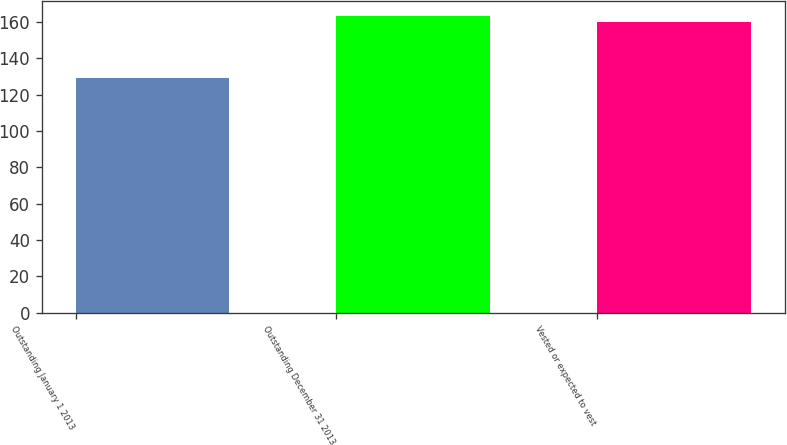Convert chart. <chart><loc_0><loc_0><loc_500><loc_500><bar_chart><fcel>Outstanding January 1 2013<fcel>Outstanding December 31 2013<fcel>Vested or expected to vest<nl><fcel>129<fcel>163.4<fcel>160<nl></chart> 